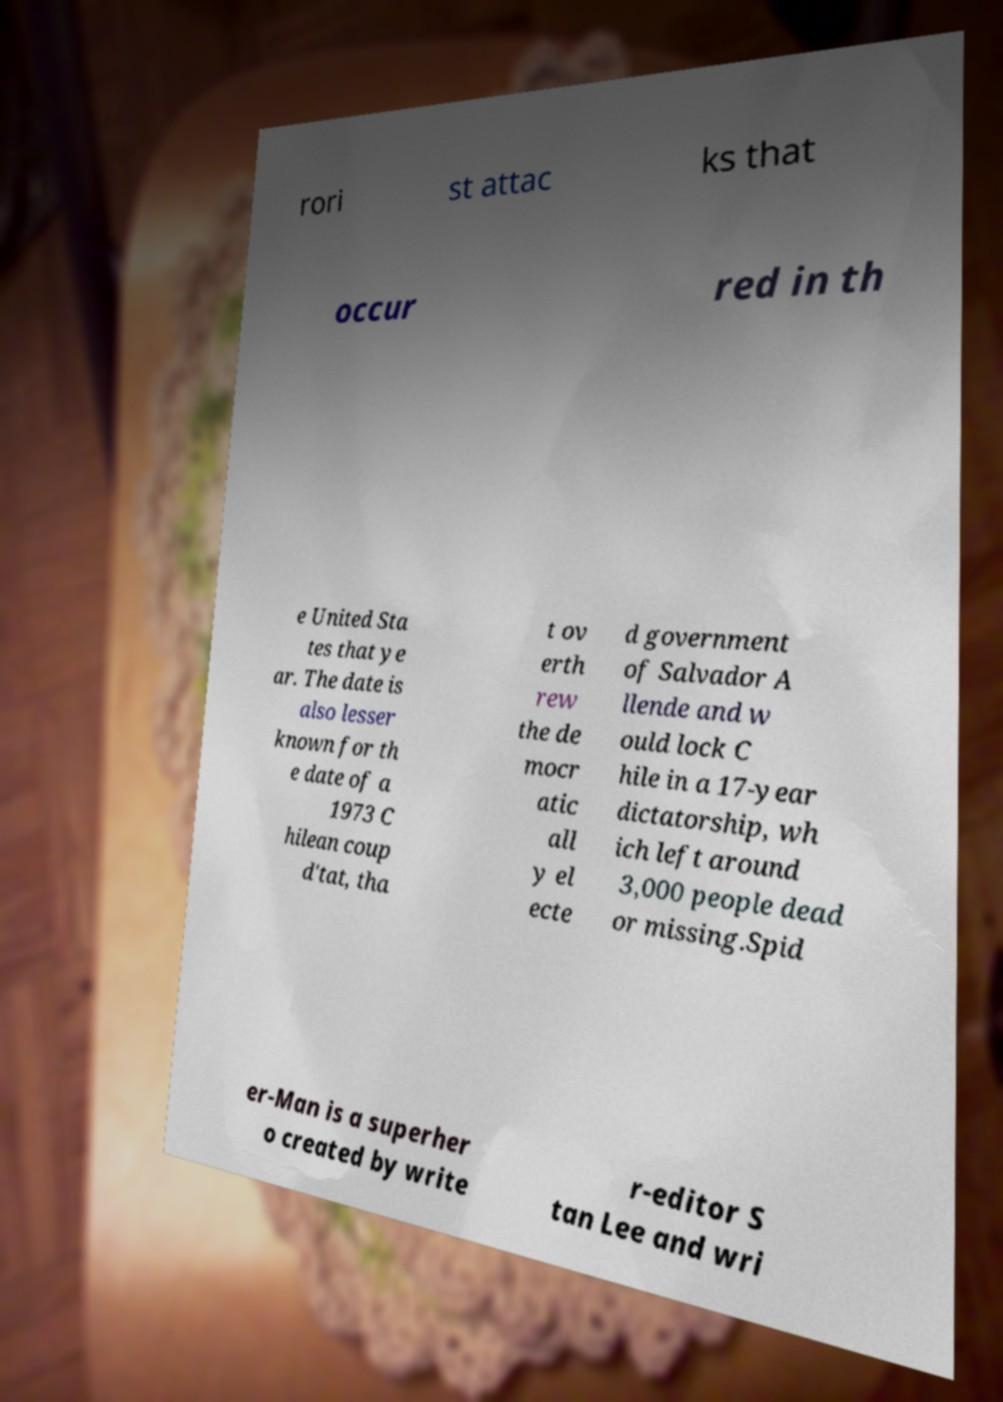What messages or text are displayed in this image? I need them in a readable, typed format. rori st attac ks that occur red in th e United Sta tes that ye ar. The date is also lesser known for th e date of a 1973 C hilean coup d'tat, tha t ov erth rew the de mocr atic all y el ecte d government of Salvador A llende and w ould lock C hile in a 17-year dictatorship, wh ich left around 3,000 people dead or missing.Spid er-Man is a superher o created by write r-editor S tan Lee and wri 